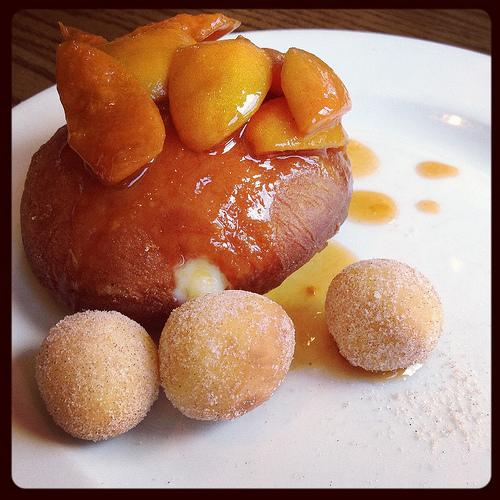Mention the table, the plate and the content it has in a short sentence. A wooden table holds a white plate with a doughnut topped with caramelized peaches and three small doughnut balls. Describe the dessert in the image by mentioning the ingredients and how it is served. The dessert consists of a doughnut topped with caramelized peaches and accompanied by three small sugar-coated doughnut balls, served on a white plate placed on a wooden table. In a descriptive manner, discuss the type of food in the image and how it is presented. There is a delicious-looking doughnut topped with juicy caramelized peaches, alongside three small sugar-coated doughnut balls, attractively arranged on a round white plate. What is the highlighted dessert in the image, including its toppings and serving? The dessert is a doughnut topped with caramelized peaches and accompanied by three small doughnut balls, served on a white plate. In a casual tone, describe the food item in the image and how it looks. The doughnut topped with caramelized peaches and the little doughnut balls on the white plate look super tempting! Write a simple sentence describing the main focus of the image. The image showcases a doughnut topped with caramelized peaches and small doughnut balls on a white plate. What are the key components of the image scene and the food preparation? The scene includes a wooden table, a white plate, a doughnut topped with caramelized peaches, and three small doughnut balls. Mention the main elements of the image including the table and the plate of food. The image features a wooden table, a white plate, a doughnut topped with caramelized peaches, and three small doughnut balls. Provide a concise description of the table setting and the food it displays. The table setting features a wooden table with a white plate holding a doughnut topped with caramelized peaches and three small doughnut balls. Provide a brief description of the primary food item in the image. A doughnut topped with caramelized peaches and accompanied by three small doughnut balls, sitting on a white plate on a wooden table. 